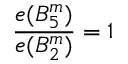<formula> <loc_0><loc_0><loc_500><loc_500>{ \frac { e ( B _ { 5 } ^ { m } ) } { e ( B _ { 2 } ^ { m } ) } } = 1</formula> 